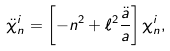Convert formula to latex. <formula><loc_0><loc_0><loc_500><loc_500>\ddot { \chi } _ { n } ^ { i } = \left [ - n ^ { 2 } + \ell ^ { 2 } \frac { \ddot { a } } { a } \right ] \chi _ { n } ^ { i } ,</formula> 